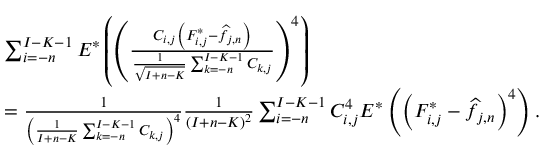<formula> <loc_0><loc_0><loc_500><loc_500>\begin{array} { r l } & { \sum _ { i = - n } ^ { I - K - 1 } E ^ { * } \left ( \left ( \frac { C _ { i , j } \left ( F _ { i , j } ^ { * } - \widehat { f } _ { j , n } \right ) } { \frac { 1 } { \sqrt { I + n - K } } \sum _ { k = - n } ^ { I - K - 1 } C _ { k , j } } \right ) ^ { 4 } \right ) } \\ & { = \frac { 1 } { \left ( \frac { 1 } { I + n - K } \sum _ { k = - n } ^ { I - K - 1 } C _ { k , j } \right ) ^ { 4 } } \frac { 1 } { ( I + n - K ) ^ { 2 } } \sum _ { i = - n } ^ { I - K - 1 } C _ { i , j } ^ { 4 } E ^ { * } \left ( \left ( F _ { i , j } ^ { * } - \widehat { f } _ { j , n } \right ) ^ { 4 } \right ) . } \end{array}</formula> 